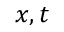Convert formula to latex. <formula><loc_0><loc_0><loc_500><loc_500>x , t</formula> 